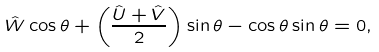<formula> <loc_0><loc_0><loc_500><loc_500>\hat { W } \cos \theta + \left ( \frac { \hat { U } + \hat { V } } { 2 } \right ) \sin \theta - \cos \theta \sin \theta = 0 ,</formula> 